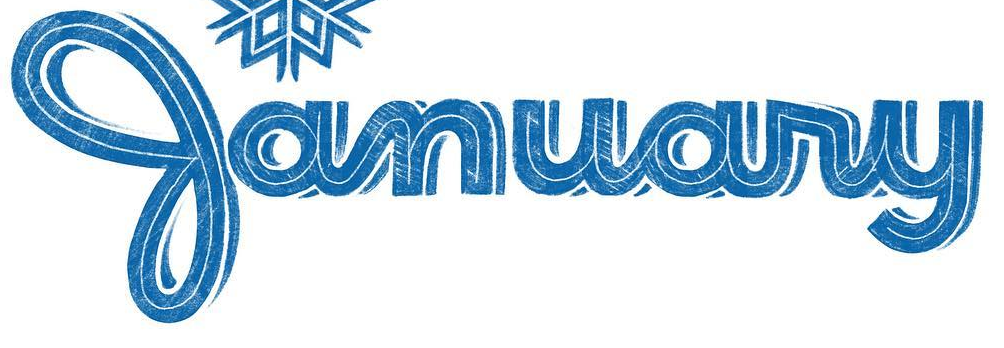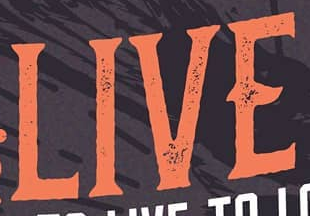What words can you see in these images in sequence, separated by a semicolon? January; LIVE 